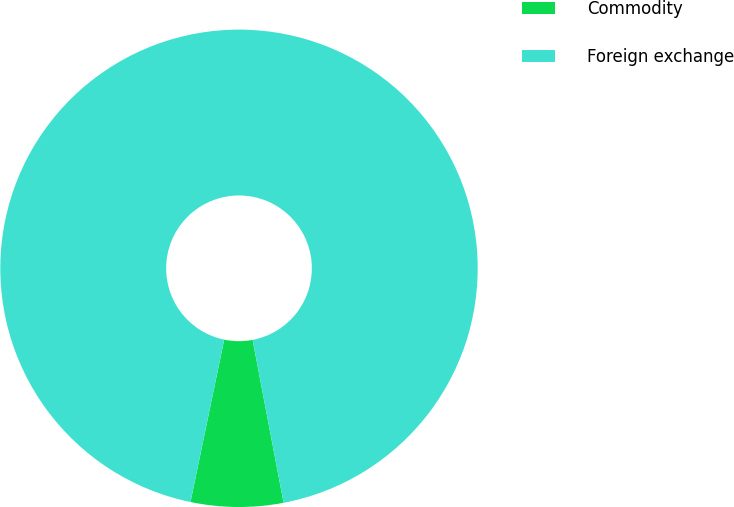<chart> <loc_0><loc_0><loc_500><loc_500><pie_chart><fcel>Commodity<fcel>Foreign exchange<nl><fcel>6.25%<fcel>93.75%<nl></chart> 